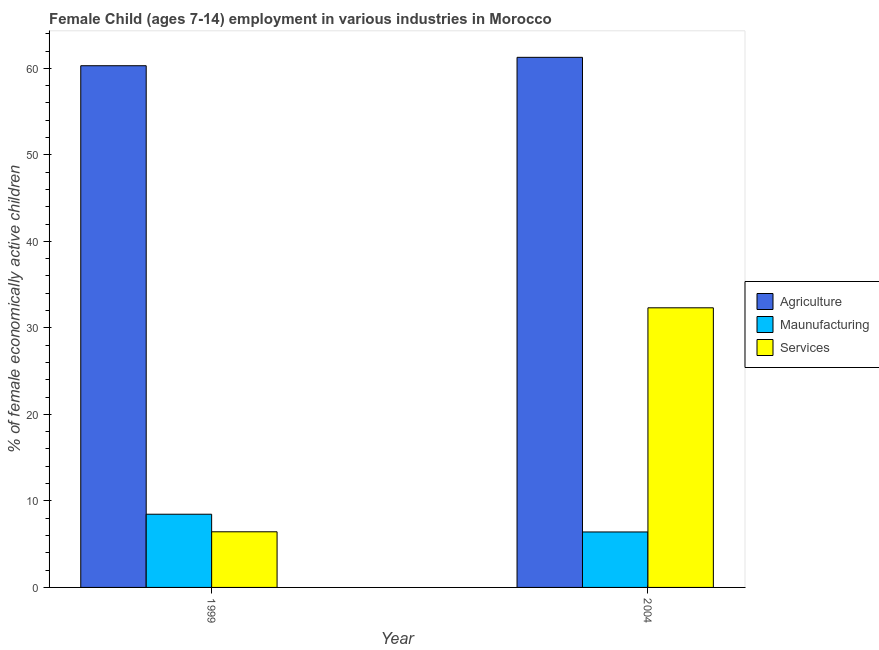How many different coloured bars are there?
Make the answer very short. 3. How many groups of bars are there?
Offer a terse response. 2. How many bars are there on the 2nd tick from the left?
Your answer should be very brief. 3. What is the label of the 1st group of bars from the left?
Your response must be concise. 1999. What is the percentage of economically active children in services in 2004?
Your answer should be compact. 32.32. Across all years, what is the maximum percentage of economically active children in services?
Offer a terse response. 32.32. Across all years, what is the minimum percentage of economically active children in manufacturing?
Your answer should be very brief. 6.41. In which year was the percentage of economically active children in services maximum?
Your answer should be compact. 2004. What is the total percentage of economically active children in manufacturing in the graph?
Your response must be concise. 14.87. What is the difference between the percentage of economically active children in manufacturing in 1999 and that in 2004?
Your answer should be compact. 2.05. What is the difference between the percentage of economically active children in manufacturing in 1999 and the percentage of economically active children in agriculture in 2004?
Your answer should be compact. 2.05. What is the average percentage of economically active children in agriculture per year?
Provide a short and direct response. 60.78. In the year 2004, what is the difference between the percentage of economically active children in agriculture and percentage of economically active children in services?
Make the answer very short. 0. In how many years, is the percentage of economically active children in manufacturing greater than 36 %?
Provide a succinct answer. 0. What is the ratio of the percentage of economically active children in agriculture in 1999 to that in 2004?
Your answer should be very brief. 0.98. What does the 2nd bar from the left in 2004 represents?
Provide a succinct answer. Maunufacturing. What does the 3rd bar from the right in 2004 represents?
Ensure brevity in your answer.  Agriculture. Is it the case that in every year, the sum of the percentage of economically active children in agriculture and percentage of economically active children in manufacturing is greater than the percentage of economically active children in services?
Provide a succinct answer. Yes. How many bars are there?
Offer a terse response. 6. Are all the bars in the graph horizontal?
Your answer should be compact. No. How many years are there in the graph?
Give a very brief answer. 2. What is the difference between two consecutive major ticks on the Y-axis?
Your answer should be compact. 10. Are the values on the major ticks of Y-axis written in scientific E-notation?
Offer a terse response. No. Where does the legend appear in the graph?
Keep it short and to the point. Center right. How are the legend labels stacked?
Your answer should be very brief. Vertical. What is the title of the graph?
Offer a very short reply. Female Child (ages 7-14) employment in various industries in Morocco. Does "Profit Tax" appear as one of the legend labels in the graph?
Offer a very short reply. No. What is the label or title of the Y-axis?
Keep it short and to the point. % of female economically active children. What is the % of female economically active children of Agriculture in 1999?
Offer a terse response. 60.3. What is the % of female economically active children of Maunufacturing in 1999?
Ensure brevity in your answer.  8.46. What is the % of female economically active children in Services in 1999?
Provide a short and direct response. 6.43. What is the % of female economically active children in Agriculture in 2004?
Provide a succinct answer. 61.27. What is the % of female economically active children in Maunufacturing in 2004?
Your answer should be very brief. 6.41. What is the % of female economically active children of Services in 2004?
Offer a terse response. 32.32. Across all years, what is the maximum % of female economically active children in Agriculture?
Your answer should be compact. 61.27. Across all years, what is the maximum % of female economically active children in Maunufacturing?
Offer a terse response. 8.46. Across all years, what is the maximum % of female economically active children of Services?
Offer a terse response. 32.32. Across all years, what is the minimum % of female economically active children in Agriculture?
Provide a succinct answer. 60.3. Across all years, what is the minimum % of female economically active children of Maunufacturing?
Provide a succinct answer. 6.41. Across all years, what is the minimum % of female economically active children of Services?
Provide a succinct answer. 6.43. What is the total % of female economically active children of Agriculture in the graph?
Keep it short and to the point. 121.57. What is the total % of female economically active children of Maunufacturing in the graph?
Make the answer very short. 14.87. What is the total % of female economically active children of Services in the graph?
Give a very brief answer. 38.75. What is the difference between the % of female economically active children in Agriculture in 1999 and that in 2004?
Provide a succinct answer. -0.97. What is the difference between the % of female economically active children in Maunufacturing in 1999 and that in 2004?
Your response must be concise. 2.05. What is the difference between the % of female economically active children in Services in 1999 and that in 2004?
Your answer should be compact. -25.89. What is the difference between the % of female economically active children in Agriculture in 1999 and the % of female economically active children in Maunufacturing in 2004?
Offer a very short reply. 53.89. What is the difference between the % of female economically active children of Agriculture in 1999 and the % of female economically active children of Services in 2004?
Make the answer very short. 27.98. What is the difference between the % of female economically active children in Maunufacturing in 1999 and the % of female economically active children in Services in 2004?
Make the answer very short. -23.86. What is the average % of female economically active children in Agriculture per year?
Your answer should be compact. 60.78. What is the average % of female economically active children in Maunufacturing per year?
Provide a short and direct response. 7.43. What is the average % of female economically active children in Services per year?
Provide a succinct answer. 19.38. In the year 1999, what is the difference between the % of female economically active children of Agriculture and % of female economically active children of Maunufacturing?
Ensure brevity in your answer.  51.84. In the year 1999, what is the difference between the % of female economically active children of Agriculture and % of female economically active children of Services?
Provide a succinct answer. 53.87. In the year 1999, what is the difference between the % of female economically active children of Maunufacturing and % of female economically active children of Services?
Offer a very short reply. 2.03. In the year 2004, what is the difference between the % of female economically active children of Agriculture and % of female economically active children of Maunufacturing?
Make the answer very short. 54.86. In the year 2004, what is the difference between the % of female economically active children in Agriculture and % of female economically active children in Services?
Offer a very short reply. 28.95. In the year 2004, what is the difference between the % of female economically active children of Maunufacturing and % of female economically active children of Services?
Your response must be concise. -25.91. What is the ratio of the % of female economically active children of Agriculture in 1999 to that in 2004?
Give a very brief answer. 0.98. What is the ratio of the % of female economically active children of Maunufacturing in 1999 to that in 2004?
Your answer should be very brief. 1.32. What is the ratio of the % of female economically active children of Services in 1999 to that in 2004?
Your answer should be very brief. 0.2. What is the difference between the highest and the second highest % of female economically active children of Maunufacturing?
Ensure brevity in your answer.  2.05. What is the difference between the highest and the second highest % of female economically active children of Services?
Offer a very short reply. 25.89. What is the difference between the highest and the lowest % of female economically active children in Maunufacturing?
Offer a very short reply. 2.05. What is the difference between the highest and the lowest % of female economically active children of Services?
Offer a very short reply. 25.89. 